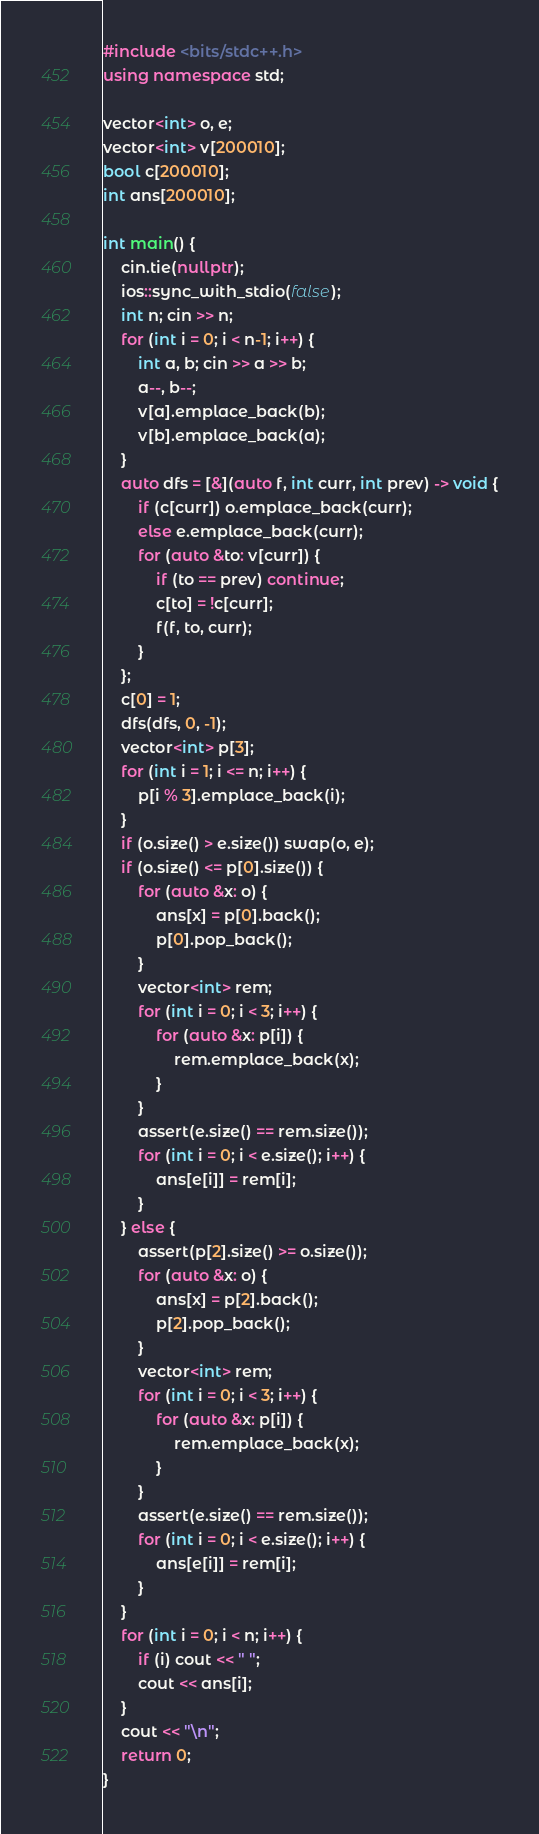<code> <loc_0><loc_0><loc_500><loc_500><_C++_>#include <bits/stdc++.h>
using namespace std;

vector<int> o, e;
vector<int> v[200010];
bool c[200010];
int ans[200010];

int main() {
    cin.tie(nullptr);
    ios::sync_with_stdio(false);
    int n; cin >> n;
    for (int i = 0; i < n-1; i++) {
        int a, b; cin >> a >> b;
        a--, b--;
        v[a].emplace_back(b);
        v[b].emplace_back(a);
    }
    auto dfs = [&](auto f, int curr, int prev) -> void {
        if (c[curr]) o.emplace_back(curr);
        else e.emplace_back(curr);
        for (auto &to: v[curr]) {
            if (to == prev) continue;
            c[to] = !c[curr];
            f(f, to, curr);
        }
    };
    c[0] = 1;
    dfs(dfs, 0, -1);
    vector<int> p[3];
    for (int i = 1; i <= n; i++) {
        p[i % 3].emplace_back(i);
    }
    if (o.size() > e.size()) swap(o, e);
    if (o.size() <= p[0].size()) {
        for (auto &x: o) {
            ans[x] = p[0].back();
            p[0].pop_back();
        }
        vector<int> rem;
        for (int i = 0; i < 3; i++) {
            for (auto &x: p[i]) {
                rem.emplace_back(x);
            }
        }
        assert(e.size() == rem.size());
        for (int i = 0; i < e.size(); i++) {
            ans[e[i]] = rem[i];
        }
    } else {
        assert(p[2].size() >= o.size());
        for (auto &x: o) {
            ans[x] = p[2].back();
            p[2].pop_back();
        }
        vector<int> rem;
        for (int i = 0; i < 3; i++) {
            for (auto &x: p[i]) {
                rem.emplace_back(x);
            }
        }
        assert(e.size() == rem.size());
        for (int i = 0; i < e.size(); i++) {
            ans[e[i]] = rem[i];
        }
    }
    for (int i = 0; i < n; i++) {
        if (i) cout << " ";
        cout << ans[i];
    }
    cout << "\n";
    return 0;
}</code> 